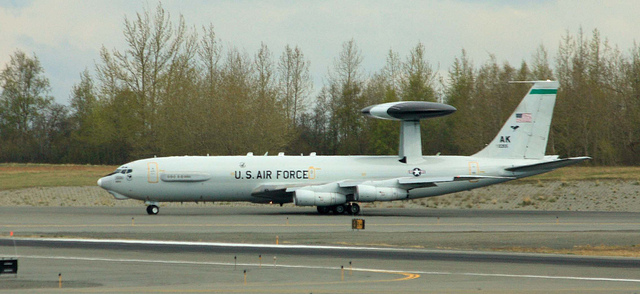Extract all visible text content from this image. U. S. AIR FORCE 